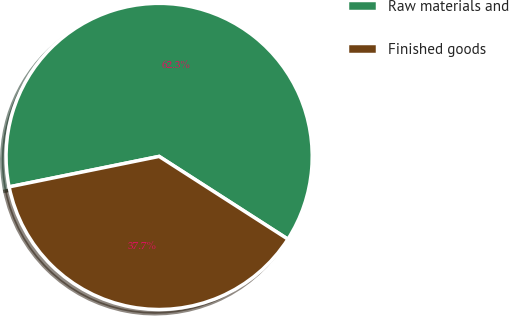Convert chart. <chart><loc_0><loc_0><loc_500><loc_500><pie_chart><fcel>Raw materials and<fcel>Finished goods<nl><fcel>62.28%<fcel>37.72%<nl></chart> 